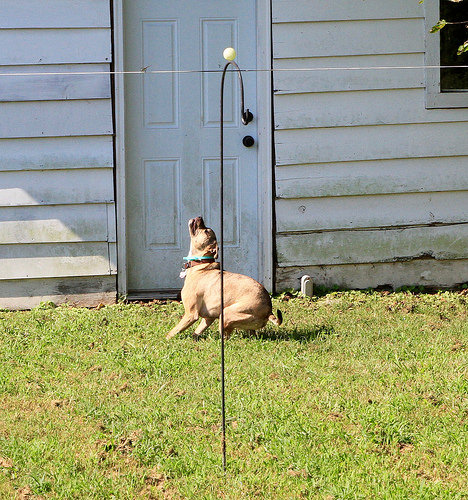<image>
Is the dog in front of the door? Yes. The dog is positioned in front of the door, appearing closer to the camera viewpoint. 